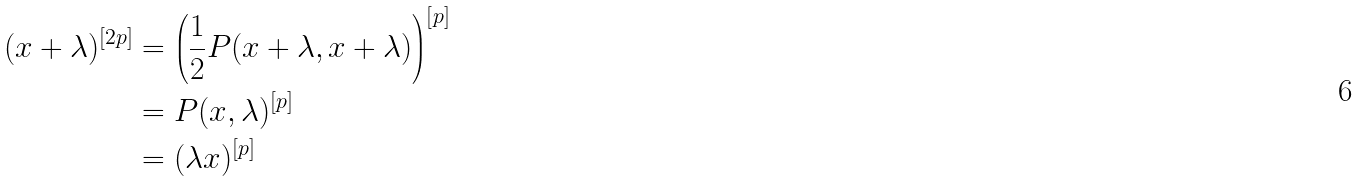<formula> <loc_0><loc_0><loc_500><loc_500>( x + \lambda ) ^ { [ 2 p ] } & = \left ( \frac { 1 } { 2 } P ( x + \lambda , x + \lambda ) \right ) ^ { [ p ] } \\ & = P ( x , \lambda ) ^ { [ p ] } \\ & = ( \lambda x ) ^ { [ p ] }</formula> 